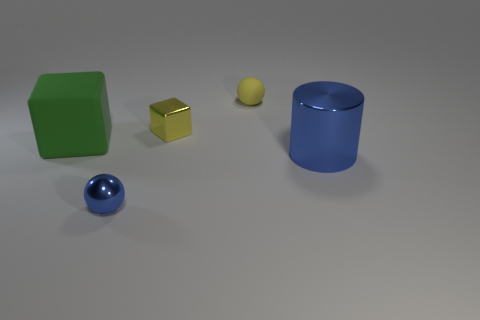What can you tell me about the arrangement of the objects? The objects appear to be deliberately placed in a linear arrangement at varying distances from the foreground to the background, creating a sense of depth. Starting from the left, there's a green cube, a small yellow ball, and a yellow cube, followed by a large blue cylinder, and finally, a blue sphere in the front. Does the arrangement of these objects serve any particular purpose? While the specific purpose of this arrangement isn't immediately clear, it could be set up to study or display characteristics such as color contrast, size progression, material texture, or the interaction of light and shadow on different shapes. It might also be used for an educational demonstration or a compositional study in photography or 3D modeling. 